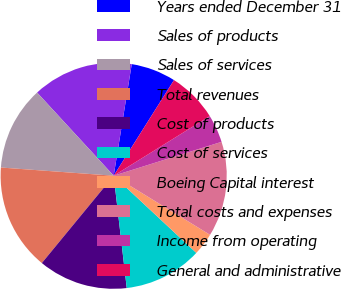Convert chart to OTSL. <chart><loc_0><loc_0><loc_500><loc_500><pie_chart><fcel>Years ended December 31<fcel>Sales of products<fcel>Sales of services<fcel>Total revenues<fcel>Cost of products<fcel>Cost of services<fcel>Boeing Capital interest<fcel>Total costs and expenses<fcel>Income from operating<fcel>General and administrative<nl><fcel>6.4%<fcel>14.4%<fcel>12.0%<fcel>15.2%<fcel>12.8%<fcel>11.2%<fcel>3.2%<fcel>13.6%<fcel>4.0%<fcel>7.2%<nl></chart> 